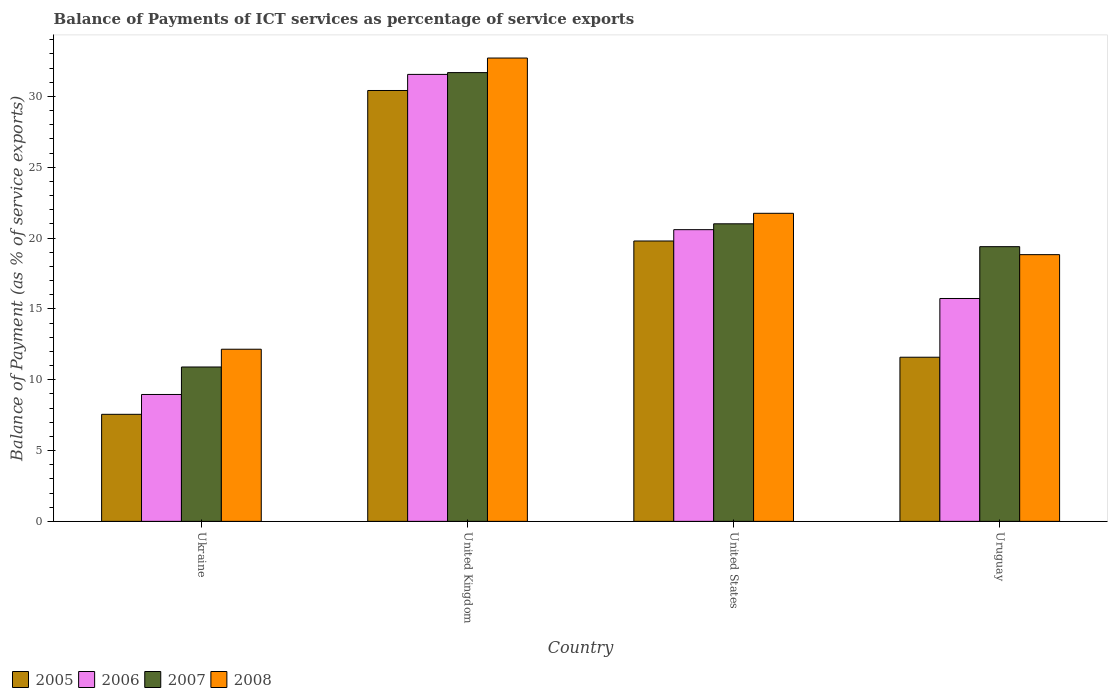How many different coloured bars are there?
Ensure brevity in your answer.  4. How many groups of bars are there?
Ensure brevity in your answer.  4. How many bars are there on the 2nd tick from the left?
Your answer should be very brief. 4. What is the label of the 2nd group of bars from the left?
Give a very brief answer. United Kingdom. What is the balance of payments of ICT services in 2006 in Ukraine?
Provide a succinct answer. 8.96. Across all countries, what is the maximum balance of payments of ICT services in 2006?
Give a very brief answer. 31.55. Across all countries, what is the minimum balance of payments of ICT services in 2007?
Keep it short and to the point. 10.9. In which country was the balance of payments of ICT services in 2008 minimum?
Give a very brief answer. Ukraine. What is the total balance of payments of ICT services in 2008 in the graph?
Provide a succinct answer. 85.42. What is the difference between the balance of payments of ICT services in 2007 in Ukraine and that in United Kingdom?
Ensure brevity in your answer.  -20.78. What is the difference between the balance of payments of ICT services in 2008 in Uruguay and the balance of payments of ICT services in 2006 in United Kingdom?
Your answer should be compact. -12.72. What is the average balance of payments of ICT services in 2008 per country?
Give a very brief answer. 21.36. What is the difference between the balance of payments of ICT services of/in 2007 and balance of payments of ICT services of/in 2008 in United Kingdom?
Your answer should be very brief. -1.03. What is the ratio of the balance of payments of ICT services in 2007 in United States to that in Uruguay?
Your answer should be very brief. 1.08. Is the balance of payments of ICT services in 2008 in United States less than that in Uruguay?
Your answer should be very brief. No. Is the difference between the balance of payments of ICT services in 2007 in Ukraine and United States greater than the difference between the balance of payments of ICT services in 2008 in Ukraine and United States?
Make the answer very short. No. What is the difference between the highest and the second highest balance of payments of ICT services in 2005?
Provide a short and direct response. -8.2. What is the difference between the highest and the lowest balance of payments of ICT services in 2008?
Your response must be concise. 20.55. What does the 2nd bar from the left in Ukraine represents?
Offer a terse response. 2006. How many bars are there?
Give a very brief answer. 16. Are all the bars in the graph horizontal?
Keep it short and to the point. No. How many countries are there in the graph?
Make the answer very short. 4. Are the values on the major ticks of Y-axis written in scientific E-notation?
Offer a terse response. No. Does the graph contain grids?
Offer a terse response. No. How many legend labels are there?
Ensure brevity in your answer.  4. What is the title of the graph?
Make the answer very short. Balance of Payments of ICT services as percentage of service exports. What is the label or title of the X-axis?
Offer a terse response. Country. What is the label or title of the Y-axis?
Provide a succinct answer. Balance of Payment (as % of service exports). What is the Balance of Payment (as % of service exports) of 2005 in Ukraine?
Give a very brief answer. 7.56. What is the Balance of Payment (as % of service exports) in 2006 in Ukraine?
Ensure brevity in your answer.  8.96. What is the Balance of Payment (as % of service exports) of 2007 in Ukraine?
Your answer should be compact. 10.9. What is the Balance of Payment (as % of service exports) in 2008 in Ukraine?
Keep it short and to the point. 12.15. What is the Balance of Payment (as % of service exports) in 2005 in United Kingdom?
Offer a very short reply. 30.41. What is the Balance of Payment (as % of service exports) of 2006 in United Kingdom?
Your answer should be very brief. 31.55. What is the Balance of Payment (as % of service exports) of 2007 in United Kingdom?
Provide a succinct answer. 31.68. What is the Balance of Payment (as % of service exports) of 2008 in United Kingdom?
Your answer should be very brief. 32.7. What is the Balance of Payment (as % of service exports) in 2005 in United States?
Your answer should be compact. 19.79. What is the Balance of Payment (as % of service exports) in 2006 in United States?
Give a very brief answer. 20.59. What is the Balance of Payment (as % of service exports) in 2007 in United States?
Your answer should be compact. 21. What is the Balance of Payment (as % of service exports) in 2008 in United States?
Make the answer very short. 21.74. What is the Balance of Payment (as % of service exports) in 2005 in Uruguay?
Provide a short and direct response. 11.59. What is the Balance of Payment (as % of service exports) of 2006 in Uruguay?
Your answer should be compact. 15.73. What is the Balance of Payment (as % of service exports) in 2007 in Uruguay?
Your answer should be very brief. 19.39. What is the Balance of Payment (as % of service exports) in 2008 in Uruguay?
Give a very brief answer. 18.83. Across all countries, what is the maximum Balance of Payment (as % of service exports) in 2005?
Offer a very short reply. 30.41. Across all countries, what is the maximum Balance of Payment (as % of service exports) in 2006?
Offer a very short reply. 31.55. Across all countries, what is the maximum Balance of Payment (as % of service exports) of 2007?
Provide a short and direct response. 31.68. Across all countries, what is the maximum Balance of Payment (as % of service exports) in 2008?
Keep it short and to the point. 32.7. Across all countries, what is the minimum Balance of Payment (as % of service exports) in 2005?
Your response must be concise. 7.56. Across all countries, what is the minimum Balance of Payment (as % of service exports) of 2006?
Offer a terse response. 8.96. Across all countries, what is the minimum Balance of Payment (as % of service exports) in 2007?
Keep it short and to the point. 10.9. Across all countries, what is the minimum Balance of Payment (as % of service exports) in 2008?
Your response must be concise. 12.15. What is the total Balance of Payment (as % of service exports) in 2005 in the graph?
Your answer should be compact. 69.34. What is the total Balance of Payment (as % of service exports) of 2006 in the graph?
Make the answer very short. 76.83. What is the total Balance of Payment (as % of service exports) of 2007 in the graph?
Keep it short and to the point. 82.96. What is the total Balance of Payment (as % of service exports) in 2008 in the graph?
Your response must be concise. 85.42. What is the difference between the Balance of Payment (as % of service exports) of 2005 in Ukraine and that in United Kingdom?
Offer a very short reply. -22.86. What is the difference between the Balance of Payment (as % of service exports) in 2006 in Ukraine and that in United Kingdom?
Make the answer very short. -22.59. What is the difference between the Balance of Payment (as % of service exports) of 2007 in Ukraine and that in United Kingdom?
Your response must be concise. -20.78. What is the difference between the Balance of Payment (as % of service exports) of 2008 in Ukraine and that in United Kingdom?
Offer a terse response. -20.55. What is the difference between the Balance of Payment (as % of service exports) in 2005 in Ukraine and that in United States?
Your answer should be very brief. -12.23. What is the difference between the Balance of Payment (as % of service exports) in 2006 in Ukraine and that in United States?
Your answer should be compact. -11.63. What is the difference between the Balance of Payment (as % of service exports) of 2007 in Ukraine and that in United States?
Keep it short and to the point. -10.11. What is the difference between the Balance of Payment (as % of service exports) in 2008 in Ukraine and that in United States?
Your answer should be very brief. -9.59. What is the difference between the Balance of Payment (as % of service exports) of 2005 in Ukraine and that in Uruguay?
Your response must be concise. -4.03. What is the difference between the Balance of Payment (as % of service exports) of 2006 in Ukraine and that in Uruguay?
Ensure brevity in your answer.  -6.77. What is the difference between the Balance of Payment (as % of service exports) of 2007 in Ukraine and that in Uruguay?
Your response must be concise. -8.49. What is the difference between the Balance of Payment (as % of service exports) of 2008 in Ukraine and that in Uruguay?
Make the answer very short. -6.68. What is the difference between the Balance of Payment (as % of service exports) in 2005 in United Kingdom and that in United States?
Your answer should be compact. 10.62. What is the difference between the Balance of Payment (as % of service exports) in 2006 in United Kingdom and that in United States?
Ensure brevity in your answer.  10.96. What is the difference between the Balance of Payment (as % of service exports) in 2007 in United Kingdom and that in United States?
Provide a short and direct response. 10.67. What is the difference between the Balance of Payment (as % of service exports) of 2008 in United Kingdom and that in United States?
Provide a short and direct response. 10.96. What is the difference between the Balance of Payment (as % of service exports) in 2005 in United Kingdom and that in Uruguay?
Offer a terse response. 18.83. What is the difference between the Balance of Payment (as % of service exports) of 2006 in United Kingdom and that in Uruguay?
Keep it short and to the point. 15.82. What is the difference between the Balance of Payment (as % of service exports) of 2007 in United Kingdom and that in Uruguay?
Keep it short and to the point. 12.29. What is the difference between the Balance of Payment (as % of service exports) in 2008 in United Kingdom and that in Uruguay?
Make the answer very short. 13.88. What is the difference between the Balance of Payment (as % of service exports) of 2005 in United States and that in Uruguay?
Give a very brief answer. 8.2. What is the difference between the Balance of Payment (as % of service exports) in 2006 in United States and that in Uruguay?
Offer a very short reply. 4.86. What is the difference between the Balance of Payment (as % of service exports) in 2007 in United States and that in Uruguay?
Your answer should be very brief. 1.61. What is the difference between the Balance of Payment (as % of service exports) in 2008 in United States and that in Uruguay?
Offer a terse response. 2.92. What is the difference between the Balance of Payment (as % of service exports) of 2005 in Ukraine and the Balance of Payment (as % of service exports) of 2006 in United Kingdom?
Give a very brief answer. -23.99. What is the difference between the Balance of Payment (as % of service exports) of 2005 in Ukraine and the Balance of Payment (as % of service exports) of 2007 in United Kingdom?
Make the answer very short. -24.12. What is the difference between the Balance of Payment (as % of service exports) of 2005 in Ukraine and the Balance of Payment (as % of service exports) of 2008 in United Kingdom?
Offer a very short reply. -25.15. What is the difference between the Balance of Payment (as % of service exports) in 2006 in Ukraine and the Balance of Payment (as % of service exports) in 2007 in United Kingdom?
Offer a very short reply. -22.72. What is the difference between the Balance of Payment (as % of service exports) of 2006 in Ukraine and the Balance of Payment (as % of service exports) of 2008 in United Kingdom?
Keep it short and to the point. -23.75. What is the difference between the Balance of Payment (as % of service exports) in 2007 in Ukraine and the Balance of Payment (as % of service exports) in 2008 in United Kingdom?
Offer a terse response. -21.81. What is the difference between the Balance of Payment (as % of service exports) in 2005 in Ukraine and the Balance of Payment (as % of service exports) in 2006 in United States?
Offer a very short reply. -13.03. What is the difference between the Balance of Payment (as % of service exports) in 2005 in Ukraine and the Balance of Payment (as % of service exports) in 2007 in United States?
Ensure brevity in your answer.  -13.45. What is the difference between the Balance of Payment (as % of service exports) of 2005 in Ukraine and the Balance of Payment (as % of service exports) of 2008 in United States?
Give a very brief answer. -14.19. What is the difference between the Balance of Payment (as % of service exports) in 2006 in Ukraine and the Balance of Payment (as % of service exports) in 2007 in United States?
Your answer should be very brief. -12.05. What is the difference between the Balance of Payment (as % of service exports) of 2006 in Ukraine and the Balance of Payment (as % of service exports) of 2008 in United States?
Your answer should be compact. -12.79. What is the difference between the Balance of Payment (as % of service exports) in 2007 in Ukraine and the Balance of Payment (as % of service exports) in 2008 in United States?
Your response must be concise. -10.85. What is the difference between the Balance of Payment (as % of service exports) in 2005 in Ukraine and the Balance of Payment (as % of service exports) in 2006 in Uruguay?
Offer a terse response. -8.18. What is the difference between the Balance of Payment (as % of service exports) in 2005 in Ukraine and the Balance of Payment (as % of service exports) in 2007 in Uruguay?
Offer a very short reply. -11.83. What is the difference between the Balance of Payment (as % of service exports) in 2005 in Ukraine and the Balance of Payment (as % of service exports) in 2008 in Uruguay?
Ensure brevity in your answer.  -11.27. What is the difference between the Balance of Payment (as % of service exports) in 2006 in Ukraine and the Balance of Payment (as % of service exports) in 2007 in Uruguay?
Your response must be concise. -10.43. What is the difference between the Balance of Payment (as % of service exports) in 2006 in Ukraine and the Balance of Payment (as % of service exports) in 2008 in Uruguay?
Offer a very short reply. -9.87. What is the difference between the Balance of Payment (as % of service exports) in 2007 in Ukraine and the Balance of Payment (as % of service exports) in 2008 in Uruguay?
Provide a short and direct response. -7.93. What is the difference between the Balance of Payment (as % of service exports) in 2005 in United Kingdom and the Balance of Payment (as % of service exports) in 2006 in United States?
Offer a terse response. 9.82. What is the difference between the Balance of Payment (as % of service exports) in 2005 in United Kingdom and the Balance of Payment (as % of service exports) in 2007 in United States?
Your answer should be very brief. 9.41. What is the difference between the Balance of Payment (as % of service exports) in 2005 in United Kingdom and the Balance of Payment (as % of service exports) in 2008 in United States?
Provide a short and direct response. 8.67. What is the difference between the Balance of Payment (as % of service exports) in 2006 in United Kingdom and the Balance of Payment (as % of service exports) in 2007 in United States?
Ensure brevity in your answer.  10.55. What is the difference between the Balance of Payment (as % of service exports) in 2006 in United Kingdom and the Balance of Payment (as % of service exports) in 2008 in United States?
Offer a very short reply. 9.8. What is the difference between the Balance of Payment (as % of service exports) in 2007 in United Kingdom and the Balance of Payment (as % of service exports) in 2008 in United States?
Ensure brevity in your answer.  9.93. What is the difference between the Balance of Payment (as % of service exports) of 2005 in United Kingdom and the Balance of Payment (as % of service exports) of 2006 in Uruguay?
Keep it short and to the point. 14.68. What is the difference between the Balance of Payment (as % of service exports) in 2005 in United Kingdom and the Balance of Payment (as % of service exports) in 2007 in Uruguay?
Give a very brief answer. 11.02. What is the difference between the Balance of Payment (as % of service exports) in 2005 in United Kingdom and the Balance of Payment (as % of service exports) in 2008 in Uruguay?
Make the answer very short. 11.59. What is the difference between the Balance of Payment (as % of service exports) of 2006 in United Kingdom and the Balance of Payment (as % of service exports) of 2007 in Uruguay?
Provide a succinct answer. 12.16. What is the difference between the Balance of Payment (as % of service exports) in 2006 in United Kingdom and the Balance of Payment (as % of service exports) in 2008 in Uruguay?
Your answer should be compact. 12.72. What is the difference between the Balance of Payment (as % of service exports) in 2007 in United Kingdom and the Balance of Payment (as % of service exports) in 2008 in Uruguay?
Ensure brevity in your answer.  12.85. What is the difference between the Balance of Payment (as % of service exports) of 2005 in United States and the Balance of Payment (as % of service exports) of 2006 in Uruguay?
Your response must be concise. 4.06. What is the difference between the Balance of Payment (as % of service exports) of 2005 in United States and the Balance of Payment (as % of service exports) of 2007 in Uruguay?
Keep it short and to the point. 0.4. What is the difference between the Balance of Payment (as % of service exports) in 2005 in United States and the Balance of Payment (as % of service exports) in 2008 in Uruguay?
Your response must be concise. 0.96. What is the difference between the Balance of Payment (as % of service exports) of 2006 in United States and the Balance of Payment (as % of service exports) of 2007 in Uruguay?
Give a very brief answer. 1.2. What is the difference between the Balance of Payment (as % of service exports) of 2006 in United States and the Balance of Payment (as % of service exports) of 2008 in Uruguay?
Offer a terse response. 1.76. What is the difference between the Balance of Payment (as % of service exports) in 2007 in United States and the Balance of Payment (as % of service exports) in 2008 in Uruguay?
Your response must be concise. 2.18. What is the average Balance of Payment (as % of service exports) in 2005 per country?
Provide a succinct answer. 17.34. What is the average Balance of Payment (as % of service exports) in 2006 per country?
Your response must be concise. 19.21. What is the average Balance of Payment (as % of service exports) in 2007 per country?
Your answer should be compact. 20.74. What is the average Balance of Payment (as % of service exports) of 2008 per country?
Your answer should be very brief. 21.36. What is the difference between the Balance of Payment (as % of service exports) of 2005 and Balance of Payment (as % of service exports) of 2006 in Ukraine?
Provide a short and direct response. -1.4. What is the difference between the Balance of Payment (as % of service exports) in 2005 and Balance of Payment (as % of service exports) in 2007 in Ukraine?
Your response must be concise. -3.34. What is the difference between the Balance of Payment (as % of service exports) of 2005 and Balance of Payment (as % of service exports) of 2008 in Ukraine?
Your answer should be very brief. -4.59. What is the difference between the Balance of Payment (as % of service exports) in 2006 and Balance of Payment (as % of service exports) in 2007 in Ukraine?
Your response must be concise. -1.94. What is the difference between the Balance of Payment (as % of service exports) in 2006 and Balance of Payment (as % of service exports) in 2008 in Ukraine?
Give a very brief answer. -3.19. What is the difference between the Balance of Payment (as % of service exports) in 2007 and Balance of Payment (as % of service exports) in 2008 in Ukraine?
Offer a very short reply. -1.25. What is the difference between the Balance of Payment (as % of service exports) of 2005 and Balance of Payment (as % of service exports) of 2006 in United Kingdom?
Provide a succinct answer. -1.14. What is the difference between the Balance of Payment (as % of service exports) in 2005 and Balance of Payment (as % of service exports) in 2007 in United Kingdom?
Offer a very short reply. -1.26. What is the difference between the Balance of Payment (as % of service exports) in 2005 and Balance of Payment (as % of service exports) in 2008 in United Kingdom?
Your response must be concise. -2.29. What is the difference between the Balance of Payment (as % of service exports) of 2006 and Balance of Payment (as % of service exports) of 2007 in United Kingdom?
Provide a short and direct response. -0.13. What is the difference between the Balance of Payment (as % of service exports) in 2006 and Balance of Payment (as % of service exports) in 2008 in United Kingdom?
Make the answer very short. -1.16. What is the difference between the Balance of Payment (as % of service exports) in 2007 and Balance of Payment (as % of service exports) in 2008 in United Kingdom?
Your response must be concise. -1.03. What is the difference between the Balance of Payment (as % of service exports) of 2005 and Balance of Payment (as % of service exports) of 2006 in United States?
Provide a short and direct response. -0.8. What is the difference between the Balance of Payment (as % of service exports) in 2005 and Balance of Payment (as % of service exports) in 2007 in United States?
Offer a very short reply. -1.21. What is the difference between the Balance of Payment (as % of service exports) of 2005 and Balance of Payment (as % of service exports) of 2008 in United States?
Make the answer very short. -1.95. What is the difference between the Balance of Payment (as % of service exports) in 2006 and Balance of Payment (as % of service exports) in 2007 in United States?
Make the answer very short. -0.41. What is the difference between the Balance of Payment (as % of service exports) of 2006 and Balance of Payment (as % of service exports) of 2008 in United States?
Ensure brevity in your answer.  -1.15. What is the difference between the Balance of Payment (as % of service exports) of 2007 and Balance of Payment (as % of service exports) of 2008 in United States?
Give a very brief answer. -0.74. What is the difference between the Balance of Payment (as % of service exports) of 2005 and Balance of Payment (as % of service exports) of 2006 in Uruguay?
Your answer should be compact. -4.15. What is the difference between the Balance of Payment (as % of service exports) in 2005 and Balance of Payment (as % of service exports) in 2007 in Uruguay?
Ensure brevity in your answer.  -7.8. What is the difference between the Balance of Payment (as % of service exports) of 2005 and Balance of Payment (as % of service exports) of 2008 in Uruguay?
Make the answer very short. -7.24. What is the difference between the Balance of Payment (as % of service exports) of 2006 and Balance of Payment (as % of service exports) of 2007 in Uruguay?
Your answer should be very brief. -3.66. What is the difference between the Balance of Payment (as % of service exports) in 2006 and Balance of Payment (as % of service exports) in 2008 in Uruguay?
Your answer should be very brief. -3.09. What is the difference between the Balance of Payment (as % of service exports) of 2007 and Balance of Payment (as % of service exports) of 2008 in Uruguay?
Keep it short and to the point. 0.56. What is the ratio of the Balance of Payment (as % of service exports) of 2005 in Ukraine to that in United Kingdom?
Offer a terse response. 0.25. What is the ratio of the Balance of Payment (as % of service exports) in 2006 in Ukraine to that in United Kingdom?
Make the answer very short. 0.28. What is the ratio of the Balance of Payment (as % of service exports) of 2007 in Ukraine to that in United Kingdom?
Your answer should be very brief. 0.34. What is the ratio of the Balance of Payment (as % of service exports) in 2008 in Ukraine to that in United Kingdom?
Your answer should be compact. 0.37. What is the ratio of the Balance of Payment (as % of service exports) of 2005 in Ukraine to that in United States?
Make the answer very short. 0.38. What is the ratio of the Balance of Payment (as % of service exports) of 2006 in Ukraine to that in United States?
Offer a terse response. 0.43. What is the ratio of the Balance of Payment (as % of service exports) in 2007 in Ukraine to that in United States?
Offer a very short reply. 0.52. What is the ratio of the Balance of Payment (as % of service exports) in 2008 in Ukraine to that in United States?
Provide a succinct answer. 0.56. What is the ratio of the Balance of Payment (as % of service exports) of 2005 in Ukraine to that in Uruguay?
Provide a short and direct response. 0.65. What is the ratio of the Balance of Payment (as % of service exports) in 2006 in Ukraine to that in Uruguay?
Offer a terse response. 0.57. What is the ratio of the Balance of Payment (as % of service exports) of 2007 in Ukraine to that in Uruguay?
Your answer should be very brief. 0.56. What is the ratio of the Balance of Payment (as % of service exports) of 2008 in Ukraine to that in Uruguay?
Offer a terse response. 0.65. What is the ratio of the Balance of Payment (as % of service exports) of 2005 in United Kingdom to that in United States?
Your response must be concise. 1.54. What is the ratio of the Balance of Payment (as % of service exports) of 2006 in United Kingdom to that in United States?
Provide a succinct answer. 1.53. What is the ratio of the Balance of Payment (as % of service exports) of 2007 in United Kingdom to that in United States?
Offer a terse response. 1.51. What is the ratio of the Balance of Payment (as % of service exports) in 2008 in United Kingdom to that in United States?
Give a very brief answer. 1.5. What is the ratio of the Balance of Payment (as % of service exports) of 2005 in United Kingdom to that in Uruguay?
Provide a succinct answer. 2.62. What is the ratio of the Balance of Payment (as % of service exports) in 2006 in United Kingdom to that in Uruguay?
Your answer should be compact. 2.01. What is the ratio of the Balance of Payment (as % of service exports) of 2007 in United Kingdom to that in Uruguay?
Your answer should be very brief. 1.63. What is the ratio of the Balance of Payment (as % of service exports) in 2008 in United Kingdom to that in Uruguay?
Ensure brevity in your answer.  1.74. What is the ratio of the Balance of Payment (as % of service exports) in 2005 in United States to that in Uruguay?
Ensure brevity in your answer.  1.71. What is the ratio of the Balance of Payment (as % of service exports) of 2006 in United States to that in Uruguay?
Provide a succinct answer. 1.31. What is the ratio of the Balance of Payment (as % of service exports) in 2007 in United States to that in Uruguay?
Provide a short and direct response. 1.08. What is the ratio of the Balance of Payment (as % of service exports) of 2008 in United States to that in Uruguay?
Give a very brief answer. 1.16. What is the difference between the highest and the second highest Balance of Payment (as % of service exports) in 2005?
Provide a succinct answer. 10.62. What is the difference between the highest and the second highest Balance of Payment (as % of service exports) of 2006?
Provide a succinct answer. 10.96. What is the difference between the highest and the second highest Balance of Payment (as % of service exports) of 2007?
Offer a terse response. 10.67. What is the difference between the highest and the second highest Balance of Payment (as % of service exports) in 2008?
Your answer should be very brief. 10.96. What is the difference between the highest and the lowest Balance of Payment (as % of service exports) of 2005?
Your answer should be compact. 22.86. What is the difference between the highest and the lowest Balance of Payment (as % of service exports) in 2006?
Ensure brevity in your answer.  22.59. What is the difference between the highest and the lowest Balance of Payment (as % of service exports) in 2007?
Keep it short and to the point. 20.78. What is the difference between the highest and the lowest Balance of Payment (as % of service exports) of 2008?
Your answer should be very brief. 20.55. 